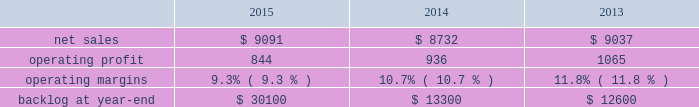$ 15 million for fire control programs due to increased deliveries ( primarily apache ) , partially offset by lower risk retirements ( primarily sniper ae ) .
Adjustments not related to volume , including net profit booking rate adjustments and other matters , were approximately $ 95 million lower for 2014 compared to 2013 .
Backlog backlog increased in 2015 compared to 2014 primarily due to higher orders on pac-3 , lantirn/sniper and certain tactical missile programs , partially offset by lower orders on thaad .
Backlog decreased in 2014 compared to 2013 primarily due to lower orders on thaad and fire control systems programs , partially offset by higher orders on certain tactical missile programs and pac-3 .
Trends we expect mfc 2019s net sales to be flat or experience a slight decline in 2016 as compared to 2015 .
Operating profit is expected to decrease by approximately 20 percent , driven by contract mix and fewer risk retirements in 2016 compared to 2015 .
Accordingly , operating profit margin is expected to decline from 2015 levels .
Mission systems and training as previously described , on november 6 , 2015 , we acquired sikorsky and aligned the sikorsky business under our mst business segment .
The results of the acquired sikorsky business have been included in our financial results from the november 6 , 2015 acquisition date through december 31 , 2015 .
As a result , our consolidated operating results and mst business segment operating results for the year ended december 31 , 2015 do not reflect a full year of sikorsky operations .
Our mst business segment provides design , manufacture , service and support for a variety of military and civil helicopters , ship and submarine mission and combat systems ; mission systems and sensors for rotary and fixed-wing aircraft ; sea and land-based missile defense systems ; radar systems ; the littoral combat ship ( lcs ) ; simulation and training services ; and unmanned systems and technologies .
In addition , mst supports the needs of customers in cybersecurity and delivers communication and command and control capabilities through complex mission solutions for defense applications .
Mst 2019s major programs include black hawk and seahawk helicopters , aegis combat system ( aegis ) , lcs , space fence , advanced hawkeye radar system , and tpq-53 radar system .
Mst 2019s operating results included the following ( in millions ) : .
2015 compared to 2014 mst 2019s net sales in 2015 increased $ 359 million , or 4% ( 4 % ) , compared to 2014 .
The increase was attributable to net sales of approximately $ 400 million from sikorsky , net of adjustments required to account for the acquisition of this business in the fourth quarter of 2015 ; and approximately $ 220 million for integrated warfare systems and sensors programs , primarily due to the ramp-up of recently awarded programs ( space fence ) .
These increases were partially offset by lower net sales of approximately $ 150 million for undersea systems programs due to decreased volume as a result of in-theater force reductions ( primarily persistent threat detection system ) ; and approximately $ 105 million for ship and aviation systems programs primarily due to decreased volume ( merlin capability sustainment program ) .
Mst 2019s operating profit in 2015 decreased $ 92 million , or 10% ( 10 % ) , compared to 2014 .
Operating profit decreased by approximately $ 75 million due to performance matters on an international program ; approximately $ 45 million for sikorsky due primarily to intangible amortization and adjustments required to account for the acquisition of this business in the fourth quarter of 2015 ; and approximately $ 15 million for integrated warfare systems and sensors programs , primarily due to investments made in connection with a recently awarded next generation radar technology program , partially offset by higher risk retirements ( including halifax class modernization ) .
These decreases were partially offset by approximately $ 20 million in increased operating profit for training and logistics services programs , primarily due to reserves recorded on certain programs in 2014 that were not repeated in 2015 .
Adjustments not related to volume , including net profit booking rate adjustments and other matters , were approximately $ 100 million lower in 2015 compared to 2014. .
What were average net sales for mst in millions from 2013 to 2015? 
Computations: table_average(net sales, none)
Answer: 8953.33333. 